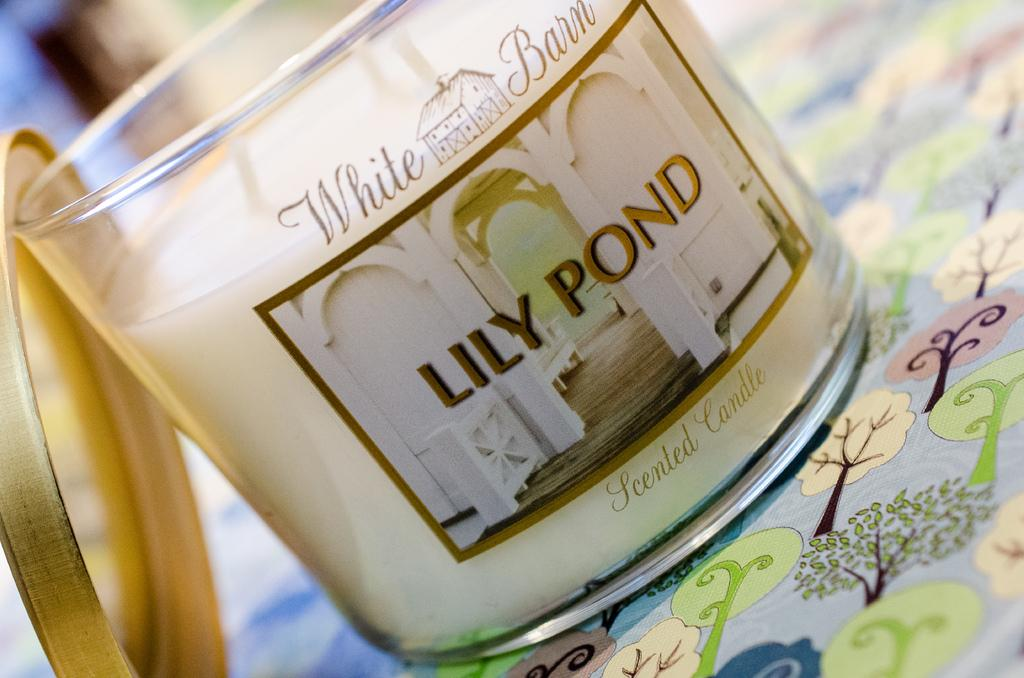Provide a one-sentence caption for the provided image. A White Barn brand scented candle in Lily Pond scent. 